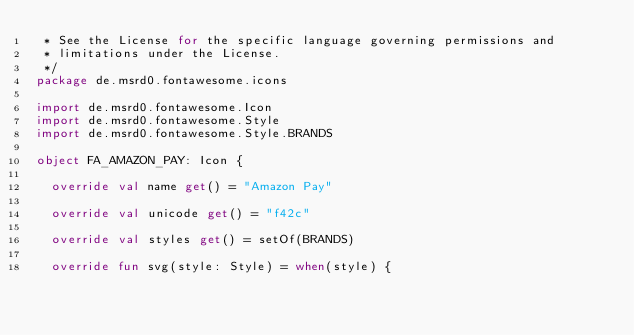Convert code to text. <code><loc_0><loc_0><loc_500><loc_500><_Kotlin_> * See the License for the specific language governing permissions and
 * limitations under the License.
 */
package de.msrd0.fontawesome.icons

import de.msrd0.fontawesome.Icon
import de.msrd0.fontawesome.Style
import de.msrd0.fontawesome.Style.BRANDS

object FA_AMAZON_PAY: Icon {
	
	override val name get() = "Amazon Pay"
	
	override val unicode get() = "f42c"
	
	override val styles get() = setOf(BRANDS)
	
	override fun svg(style: Style) = when(style) {</code> 